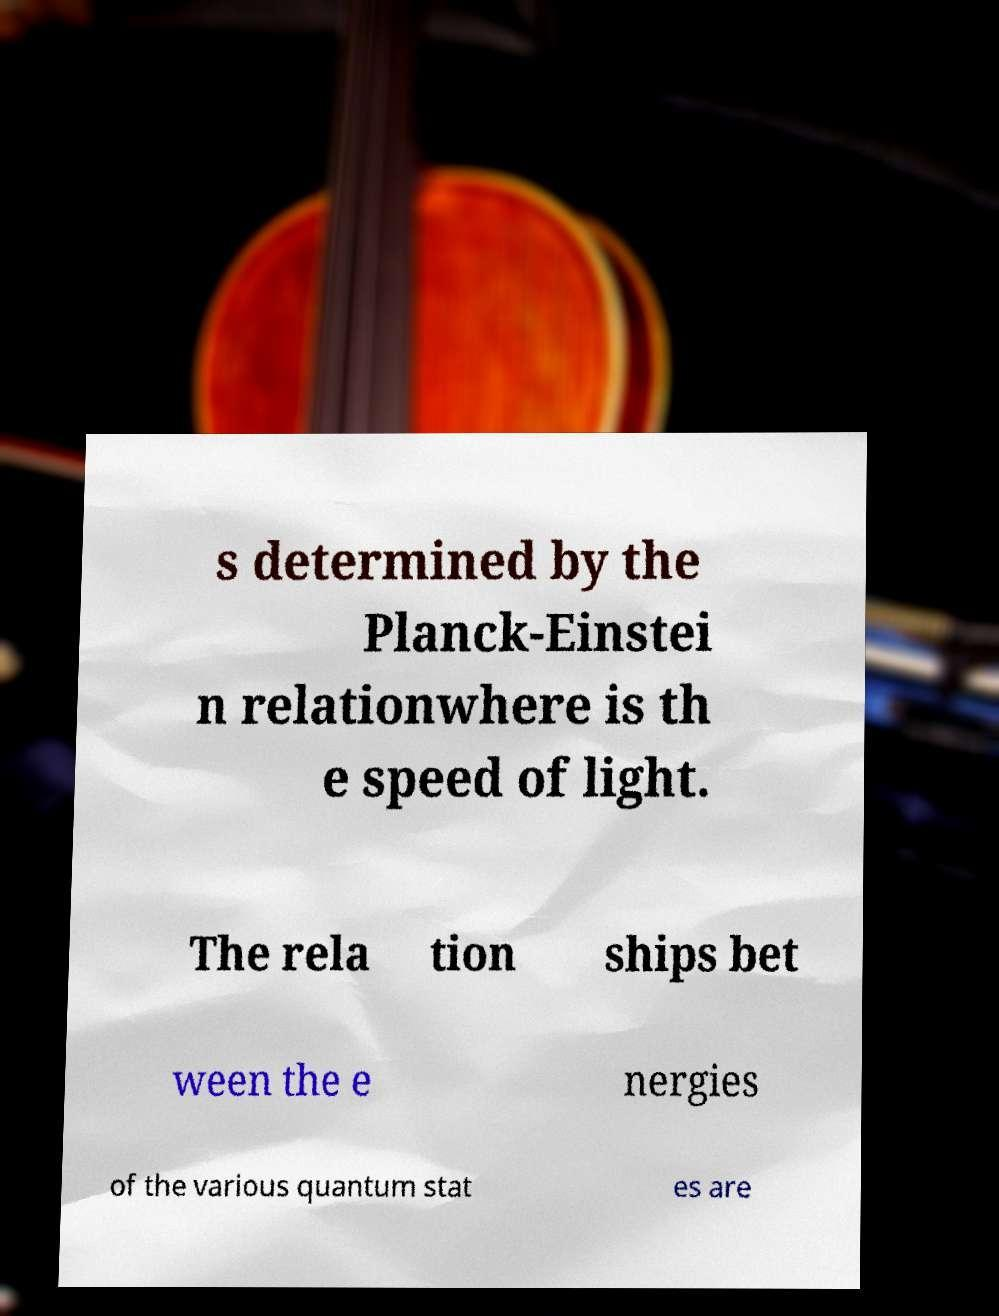Can you read and provide the text displayed in the image?This photo seems to have some interesting text. Can you extract and type it out for me? s determined by the Planck-Einstei n relationwhere is th e speed of light. The rela tion ships bet ween the e nergies of the various quantum stat es are 